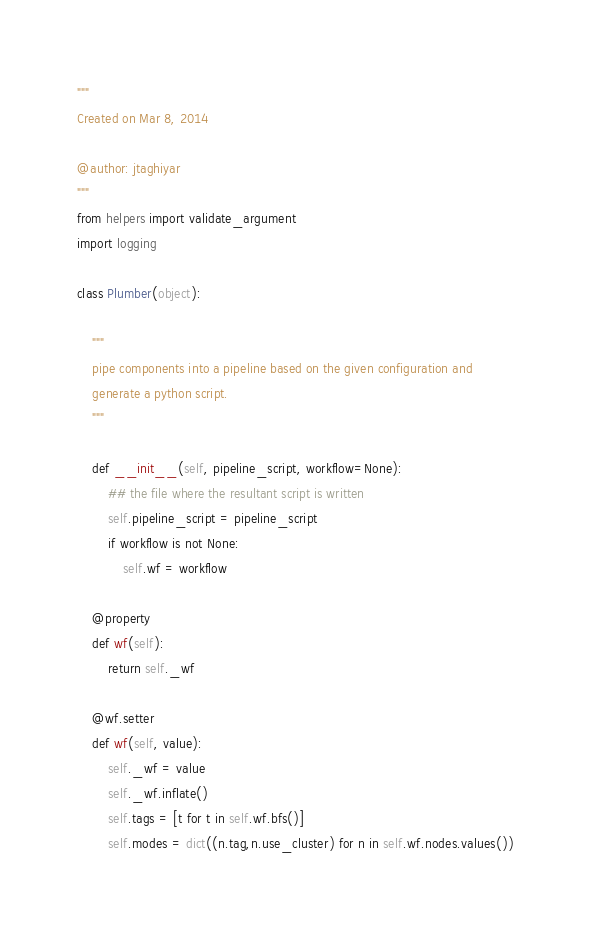Convert code to text. <code><loc_0><loc_0><loc_500><loc_500><_Python_>"""
Created on Mar 8, 2014

@author: jtaghiyar
"""
from helpers import validate_argument
import logging

class Plumber(object):

    """
    pipe components into a pipeline based on the given configuration and
    generate a python script.
    """

    def __init__(self, pipeline_script, workflow=None):
        ## the file where the resultant script is written
        self.pipeline_script = pipeline_script
        if workflow is not None:
            self.wf = workflow

    @property
    def wf(self):
        return self._wf
    
    @wf.setter
    def wf(self, value):
        self._wf = value
        self._wf.inflate()
        self.tags = [t for t in self.wf.bfs()]
        self.modes = dict((n.tag,n.use_cluster) for n in self.wf.nodes.values())</code> 